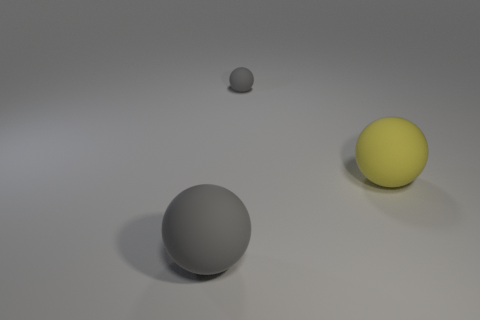Subtract all large yellow matte balls. How many balls are left? 2 Subtract all cyan blocks. How many gray spheres are left? 2 Add 1 matte things. How many objects exist? 4 Subtract all green balls. Subtract all gray blocks. How many balls are left? 3 Subtract all red rubber objects. Subtract all spheres. How many objects are left? 0 Add 3 spheres. How many spheres are left? 6 Add 3 big gray matte objects. How many big gray matte objects exist? 4 Subtract 1 yellow balls. How many objects are left? 2 